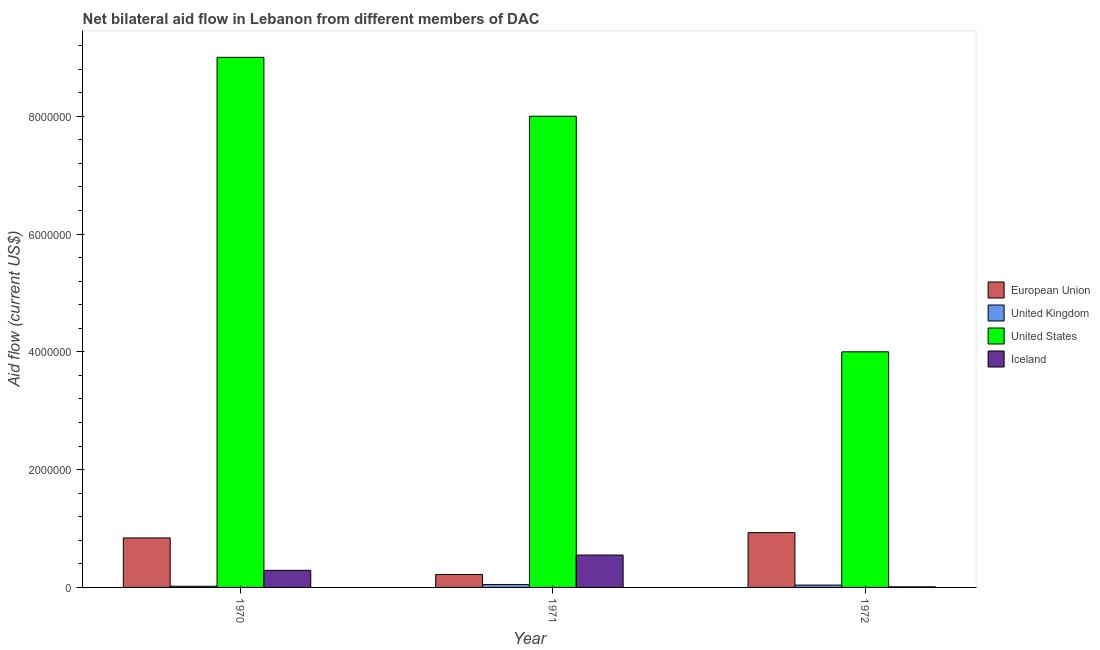Are the number of bars per tick equal to the number of legend labels?
Provide a short and direct response. Yes. Are the number of bars on each tick of the X-axis equal?
Your answer should be compact. Yes. How many bars are there on the 3rd tick from the right?
Offer a terse response. 4. In how many cases, is the number of bars for a given year not equal to the number of legend labels?
Offer a very short reply. 0. What is the amount of aid given by us in 1971?
Your response must be concise. 8.00e+06. Across all years, what is the maximum amount of aid given by iceland?
Your answer should be compact. 5.50e+05. Across all years, what is the minimum amount of aid given by eu?
Keep it short and to the point. 2.20e+05. What is the total amount of aid given by us in the graph?
Offer a terse response. 2.10e+07. What is the difference between the amount of aid given by iceland in 1970 and that in 1971?
Your answer should be very brief. -2.60e+05. What is the difference between the amount of aid given by us in 1970 and the amount of aid given by uk in 1972?
Your response must be concise. 5.00e+06. What is the average amount of aid given by us per year?
Your response must be concise. 7.00e+06. In the year 1972, what is the difference between the amount of aid given by us and amount of aid given by iceland?
Offer a very short reply. 0. What is the ratio of the amount of aid given by iceland in 1970 to that in 1971?
Your answer should be very brief. 0.53. Is the difference between the amount of aid given by iceland in 1970 and 1972 greater than the difference between the amount of aid given by eu in 1970 and 1972?
Your response must be concise. No. What is the difference between the highest and the second highest amount of aid given by uk?
Give a very brief answer. 10000. What is the difference between the highest and the lowest amount of aid given by uk?
Make the answer very short. 3.00e+04. Is the sum of the amount of aid given by us in 1970 and 1971 greater than the maximum amount of aid given by iceland across all years?
Offer a very short reply. Yes. What does the 4th bar from the right in 1971 represents?
Offer a terse response. European Union. Are all the bars in the graph horizontal?
Provide a succinct answer. No. How many years are there in the graph?
Provide a succinct answer. 3. How many legend labels are there?
Give a very brief answer. 4. What is the title of the graph?
Make the answer very short. Net bilateral aid flow in Lebanon from different members of DAC. Does "Arable land" appear as one of the legend labels in the graph?
Provide a short and direct response. No. What is the label or title of the X-axis?
Ensure brevity in your answer.  Year. What is the label or title of the Y-axis?
Offer a terse response. Aid flow (current US$). What is the Aid flow (current US$) of European Union in 1970?
Your response must be concise. 8.40e+05. What is the Aid flow (current US$) of United Kingdom in 1970?
Offer a very short reply. 2.00e+04. What is the Aid flow (current US$) of United States in 1970?
Provide a short and direct response. 9.00e+06. What is the Aid flow (current US$) in Iceland in 1970?
Keep it short and to the point. 2.90e+05. What is the Aid flow (current US$) of United Kingdom in 1971?
Your answer should be compact. 5.00e+04. What is the Aid flow (current US$) in United States in 1971?
Provide a succinct answer. 8.00e+06. What is the Aid flow (current US$) in Iceland in 1971?
Your response must be concise. 5.50e+05. What is the Aid flow (current US$) of European Union in 1972?
Provide a succinct answer. 9.30e+05. What is the Aid flow (current US$) of United States in 1972?
Provide a short and direct response. 4.00e+06. Across all years, what is the maximum Aid flow (current US$) of European Union?
Offer a terse response. 9.30e+05. Across all years, what is the maximum Aid flow (current US$) in United Kingdom?
Your answer should be compact. 5.00e+04. Across all years, what is the maximum Aid flow (current US$) of United States?
Offer a terse response. 9.00e+06. Across all years, what is the maximum Aid flow (current US$) in Iceland?
Provide a short and direct response. 5.50e+05. Across all years, what is the minimum Aid flow (current US$) of United Kingdom?
Your answer should be compact. 2.00e+04. Across all years, what is the minimum Aid flow (current US$) in Iceland?
Provide a succinct answer. 10000. What is the total Aid flow (current US$) in European Union in the graph?
Make the answer very short. 1.99e+06. What is the total Aid flow (current US$) of United Kingdom in the graph?
Your answer should be compact. 1.10e+05. What is the total Aid flow (current US$) of United States in the graph?
Offer a very short reply. 2.10e+07. What is the total Aid flow (current US$) in Iceland in the graph?
Provide a succinct answer. 8.50e+05. What is the difference between the Aid flow (current US$) in European Union in 1970 and that in 1971?
Make the answer very short. 6.20e+05. What is the difference between the Aid flow (current US$) of Iceland in 1970 and that in 1971?
Offer a terse response. -2.60e+05. What is the difference between the Aid flow (current US$) of European Union in 1970 and that in 1972?
Provide a succinct answer. -9.00e+04. What is the difference between the Aid flow (current US$) of United Kingdom in 1970 and that in 1972?
Give a very brief answer. -2.00e+04. What is the difference between the Aid flow (current US$) in United States in 1970 and that in 1972?
Provide a short and direct response. 5.00e+06. What is the difference between the Aid flow (current US$) of European Union in 1971 and that in 1972?
Give a very brief answer. -7.10e+05. What is the difference between the Aid flow (current US$) of United States in 1971 and that in 1972?
Your answer should be compact. 4.00e+06. What is the difference between the Aid flow (current US$) in Iceland in 1971 and that in 1972?
Provide a short and direct response. 5.40e+05. What is the difference between the Aid flow (current US$) of European Union in 1970 and the Aid flow (current US$) of United Kingdom in 1971?
Offer a very short reply. 7.90e+05. What is the difference between the Aid flow (current US$) in European Union in 1970 and the Aid flow (current US$) in United States in 1971?
Your answer should be compact. -7.16e+06. What is the difference between the Aid flow (current US$) in European Union in 1970 and the Aid flow (current US$) in Iceland in 1971?
Ensure brevity in your answer.  2.90e+05. What is the difference between the Aid flow (current US$) of United Kingdom in 1970 and the Aid flow (current US$) of United States in 1971?
Make the answer very short. -7.98e+06. What is the difference between the Aid flow (current US$) of United Kingdom in 1970 and the Aid flow (current US$) of Iceland in 1971?
Ensure brevity in your answer.  -5.30e+05. What is the difference between the Aid flow (current US$) of United States in 1970 and the Aid flow (current US$) of Iceland in 1971?
Your answer should be very brief. 8.45e+06. What is the difference between the Aid flow (current US$) in European Union in 1970 and the Aid flow (current US$) in United Kingdom in 1972?
Offer a very short reply. 8.00e+05. What is the difference between the Aid flow (current US$) in European Union in 1970 and the Aid flow (current US$) in United States in 1972?
Ensure brevity in your answer.  -3.16e+06. What is the difference between the Aid flow (current US$) of European Union in 1970 and the Aid flow (current US$) of Iceland in 1972?
Your response must be concise. 8.30e+05. What is the difference between the Aid flow (current US$) in United Kingdom in 1970 and the Aid flow (current US$) in United States in 1972?
Keep it short and to the point. -3.98e+06. What is the difference between the Aid flow (current US$) of United Kingdom in 1970 and the Aid flow (current US$) of Iceland in 1972?
Offer a terse response. 10000. What is the difference between the Aid flow (current US$) in United States in 1970 and the Aid flow (current US$) in Iceland in 1972?
Provide a short and direct response. 8.99e+06. What is the difference between the Aid flow (current US$) of European Union in 1971 and the Aid flow (current US$) of United States in 1972?
Provide a short and direct response. -3.78e+06. What is the difference between the Aid flow (current US$) in United Kingdom in 1971 and the Aid flow (current US$) in United States in 1972?
Provide a succinct answer. -3.95e+06. What is the difference between the Aid flow (current US$) of United Kingdom in 1971 and the Aid flow (current US$) of Iceland in 1972?
Your answer should be compact. 4.00e+04. What is the difference between the Aid flow (current US$) in United States in 1971 and the Aid flow (current US$) in Iceland in 1972?
Your answer should be compact. 7.99e+06. What is the average Aid flow (current US$) of European Union per year?
Give a very brief answer. 6.63e+05. What is the average Aid flow (current US$) of United Kingdom per year?
Offer a very short reply. 3.67e+04. What is the average Aid flow (current US$) in United States per year?
Your answer should be compact. 7.00e+06. What is the average Aid flow (current US$) in Iceland per year?
Your answer should be very brief. 2.83e+05. In the year 1970, what is the difference between the Aid flow (current US$) in European Union and Aid flow (current US$) in United Kingdom?
Keep it short and to the point. 8.20e+05. In the year 1970, what is the difference between the Aid flow (current US$) of European Union and Aid flow (current US$) of United States?
Provide a succinct answer. -8.16e+06. In the year 1970, what is the difference between the Aid flow (current US$) of United Kingdom and Aid flow (current US$) of United States?
Give a very brief answer. -8.98e+06. In the year 1970, what is the difference between the Aid flow (current US$) of United Kingdom and Aid flow (current US$) of Iceland?
Make the answer very short. -2.70e+05. In the year 1970, what is the difference between the Aid flow (current US$) of United States and Aid flow (current US$) of Iceland?
Your answer should be very brief. 8.71e+06. In the year 1971, what is the difference between the Aid flow (current US$) in European Union and Aid flow (current US$) in United States?
Ensure brevity in your answer.  -7.78e+06. In the year 1971, what is the difference between the Aid flow (current US$) in European Union and Aid flow (current US$) in Iceland?
Keep it short and to the point. -3.30e+05. In the year 1971, what is the difference between the Aid flow (current US$) of United Kingdom and Aid flow (current US$) of United States?
Provide a short and direct response. -7.95e+06. In the year 1971, what is the difference between the Aid flow (current US$) of United Kingdom and Aid flow (current US$) of Iceland?
Your answer should be very brief. -5.00e+05. In the year 1971, what is the difference between the Aid flow (current US$) of United States and Aid flow (current US$) of Iceland?
Your answer should be very brief. 7.45e+06. In the year 1972, what is the difference between the Aid flow (current US$) in European Union and Aid flow (current US$) in United Kingdom?
Ensure brevity in your answer.  8.90e+05. In the year 1972, what is the difference between the Aid flow (current US$) of European Union and Aid flow (current US$) of United States?
Your answer should be very brief. -3.07e+06. In the year 1972, what is the difference between the Aid flow (current US$) in European Union and Aid flow (current US$) in Iceland?
Offer a terse response. 9.20e+05. In the year 1972, what is the difference between the Aid flow (current US$) of United Kingdom and Aid flow (current US$) of United States?
Offer a very short reply. -3.96e+06. In the year 1972, what is the difference between the Aid flow (current US$) in United Kingdom and Aid flow (current US$) in Iceland?
Keep it short and to the point. 3.00e+04. In the year 1972, what is the difference between the Aid flow (current US$) of United States and Aid flow (current US$) of Iceland?
Ensure brevity in your answer.  3.99e+06. What is the ratio of the Aid flow (current US$) in European Union in 1970 to that in 1971?
Your answer should be compact. 3.82. What is the ratio of the Aid flow (current US$) of Iceland in 1970 to that in 1971?
Your answer should be very brief. 0.53. What is the ratio of the Aid flow (current US$) of European Union in 1970 to that in 1972?
Offer a very short reply. 0.9. What is the ratio of the Aid flow (current US$) in United States in 1970 to that in 1972?
Keep it short and to the point. 2.25. What is the ratio of the Aid flow (current US$) in European Union in 1971 to that in 1972?
Your answer should be very brief. 0.24. What is the difference between the highest and the second highest Aid flow (current US$) in European Union?
Your answer should be compact. 9.00e+04. What is the difference between the highest and the second highest Aid flow (current US$) of United States?
Provide a short and direct response. 1.00e+06. What is the difference between the highest and the second highest Aid flow (current US$) of Iceland?
Your answer should be compact. 2.60e+05. What is the difference between the highest and the lowest Aid flow (current US$) in European Union?
Offer a terse response. 7.10e+05. What is the difference between the highest and the lowest Aid flow (current US$) of Iceland?
Offer a terse response. 5.40e+05. 